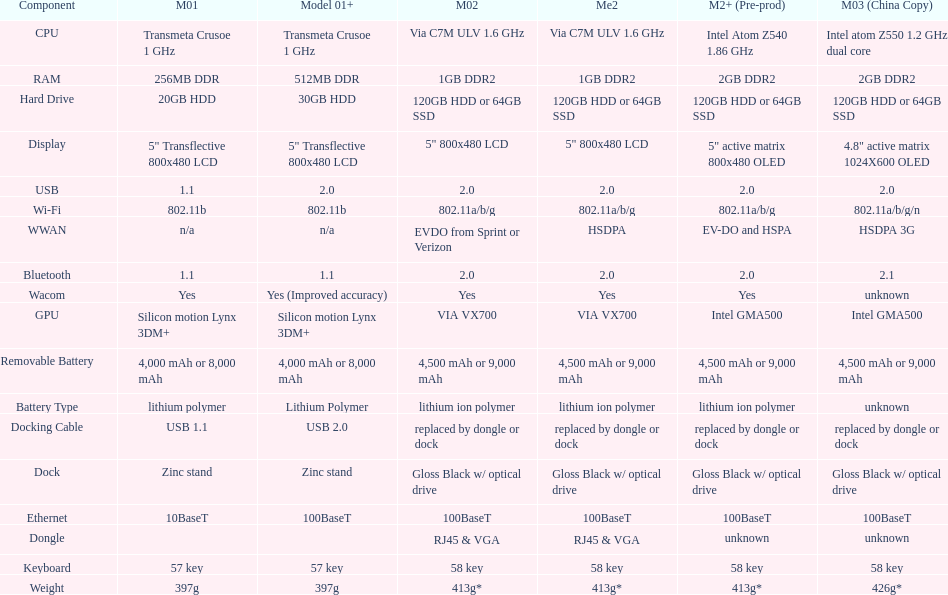What is the component before usb? Display. 